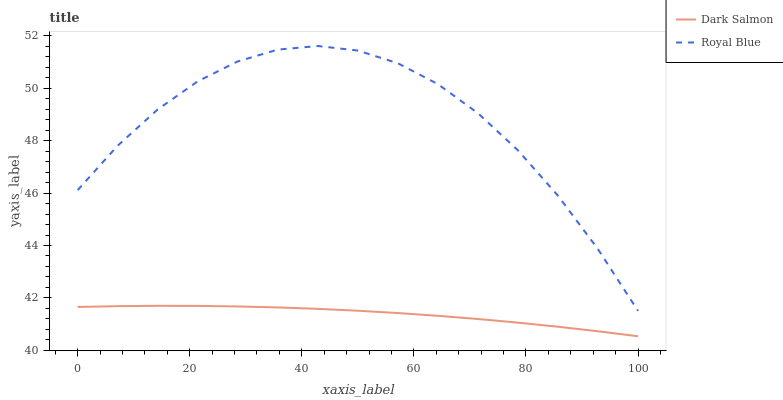Does Dark Salmon have the minimum area under the curve?
Answer yes or no. Yes. Does Royal Blue have the maximum area under the curve?
Answer yes or no. Yes. Does Dark Salmon have the maximum area under the curve?
Answer yes or no. No. Is Dark Salmon the smoothest?
Answer yes or no. Yes. Is Royal Blue the roughest?
Answer yes or no. Yes. Is Dark Salmon the roughest?
Answer yes or no. No. Does Dark Salmon have the lowest value?
Answer yes or no. Yes. Does Royal Blue have the highest value?
Answer yes or no. Yes. Does Dark Salmon have the highest value?
Answer yes or no. No. Is Dark Salmon less than Royal Blue?
Answer yes or no. Yes. Is Royal Blue greater than Dark Salmon?
Answer yes or no. Yes. Does Dark Salmon intersect Royal Blue?
Answer yes or no. No. 